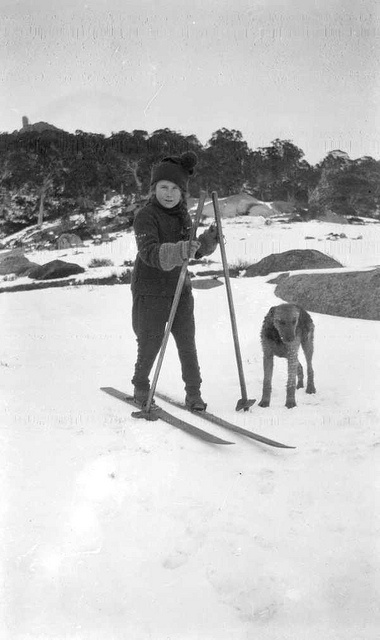Describe the objects in this image and their specific colors. I can see people in lightgray, black, gray, and white tones, dog in lightgray, gray, and black tones, and skis in lightgray, gray, and black tones in this image. 